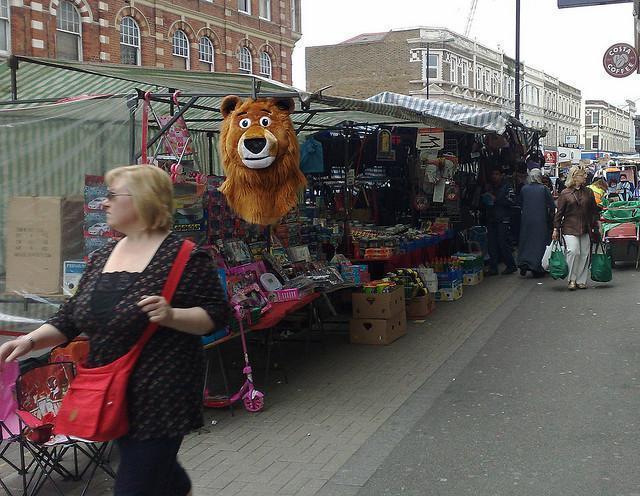Why are there stalls with products outside?
Choose the correct response, then elucidate: 'Answer: answer
Rationale: rationale.'
Options: For homeless, to decorate, to sell, for fundraising. Answer: to sell.
Rationale: The stands are set up in a public place with merchandise on display. 